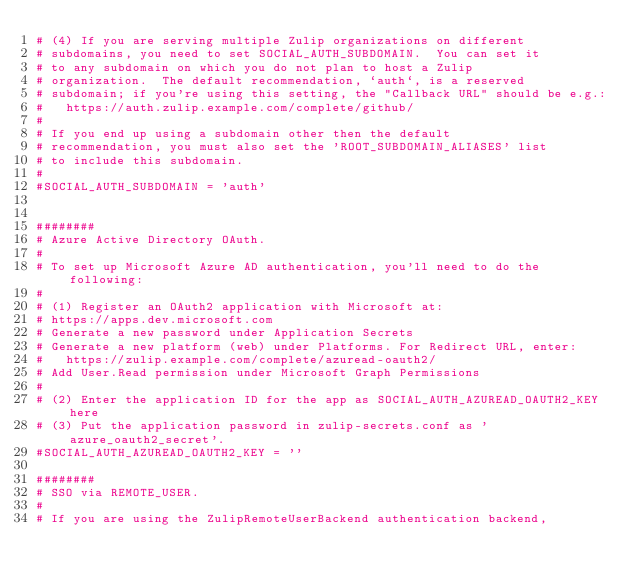Convert code to text. <code><loc_0><loc_0><loc_500><loc_500><_Python_># (4) If you are serving multiple Zulip organizations on different
# subdomains, you need to set SOCIAL_AUTH_SUBDOMAIN.  You can set it
# to any subdomain on which you do not plan to host a Zulip
# organization.  The default recommendation, `auth`, is a reserved
# subdomain; if you're using this setting, the "Callback URL" should be e.g.:
#   https://auth.zulip.example.com/complete/github/
#
# If you end up using a subdomain other then the default
# recommendation, you must also set the 'ROOT_SUBDOMAIN_ALIASES' list
# to include this subdomain.
#
#SOCIAL_AUTH_SUBDOMAIN = 'auth'


########
# Azure Active Directory OAuth.
#
# To set up Microsoft Azure AD authentication, you'll need to do the following:
#
# (1) Register an OAuth2 application with Microsoft at:
# https://apps.dev.microsoft.com
# Generate a new password under Application Secrets
# Generate a new platform (web) under Platforms. For Redirect URL, enter:
#   https://zulip.example.com/complete/azuread-oauth2/
# Add User.Read permission under Microsoft Graph Permissions
#
# (2) Enter the application ID for the app as SOCIAL_AUTH_AZUREAD_OAUTH2_KEY here
# (3) Put the application password in zulip-secrets.conf as 'azure_oauth2_secret'.
#SOCIAL_AUTH_AZUREAD_OAUTH2_KEY = ''

########
# SSO via REMOTE_USER.
#
# If you are using the ZulipRemoteUserBackend authentication backend,</code> 